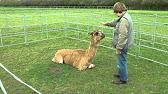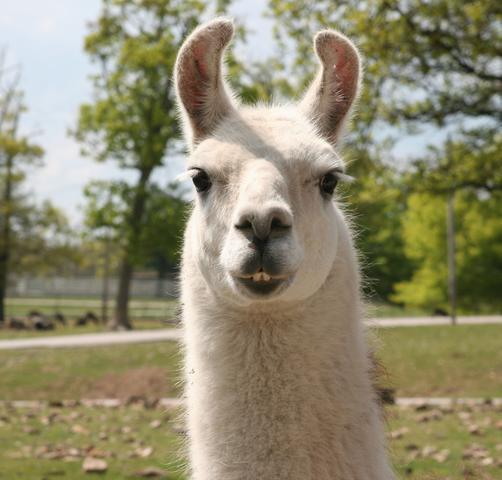The first image is the image on the left, the second image is the image on the right. Evaluate the accuracy of this statement regarding the images: "There is one human near at least one llama one oft he images.". Is it true? Answer yes or no. Yes. The first image is the image on the left, the second image is the image on the right. Evaluate the accuracy of this statement regarding the images: "There is a human interacting with the livestock.". Is it true? Answer yes or no. Yes. 